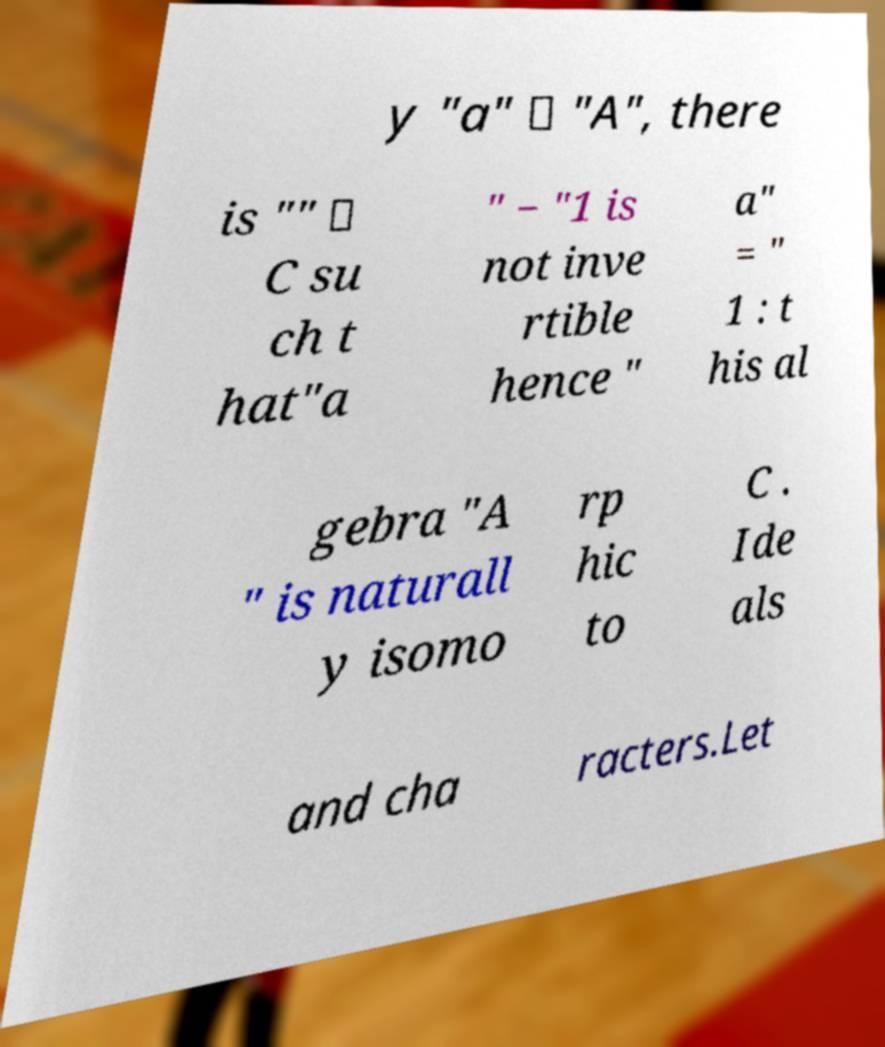What messages or text are displayed in this image? I need them in a readable, typed format. y "a" ∈ "A", there is "" ∈ C su ch t hat"a " − "1 is not inve rtible hence " a" = " 1 : t his al gebra "A " is naturall y isomo rp hic to C . Ide als and cha racters.Let 